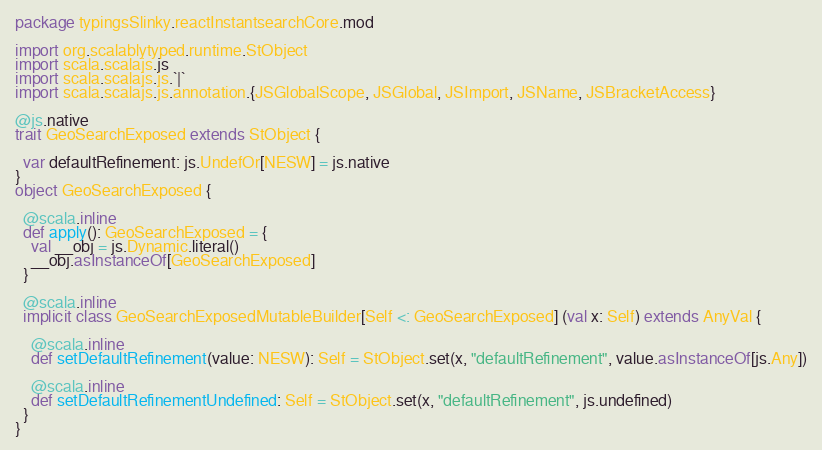<code> <loc_0><loc_0><loc_500><loc_500><_Scala_>package typingsSlinky.reactInstantsearchCore.mod

import org.scalablytyped.runtime.StObject
import scala.scalajs.js
import scala.scalajs.js.`|`
import scala.scalajs.js.annotation.{JSGlobalScope, JSGlobal, JSImport, JSName, JSBracketAccess}

@js.native
trait GeoSearchExposed extends StObject {
  
  var defaultRefinement: js.UndefOr[NESW] = js.native
}
object GeoSearchExposed {
  
  @scala.inline
  def apply(): GeoSearchExposed = {
    val __obj = js.Dynamic.literal()
    __obj.asInstanceOf[GeoSearchExposed]
  }
  
  @scala.inline
  implicit class GeoSearchExposedMutableBuilder[Self <: GeoSearchExposed] (val x: Self) extends AnyVal {
    
    @scala.inline
    def setDefaultRefinement(value: NESW): Self = StObject.set(x, "defaultRefinement", value.asInstanceOf[js.Any])
    
    @scala.inline
    def setDefaultRefinementUndefined: Self = StObject.set(x, "defaultRefinement", js.undefined)
  }
}
</code> 